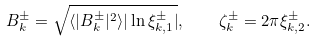Convert formula to latex. <formula><loc_0><loc_0><loc_500><loc_500>B _ { k } ^ { \pm } = \sqrt { \langle | B _ { k } ^ { \pm } | ^ { 2 } \rangle | \ln \xi _ { k , 1 } ^ { \pm } | } , \quad \zeta _ { k } ^ { \pm } = 2 \pi \xi _ { k , 2 } ^ { \pm } .</formula> 